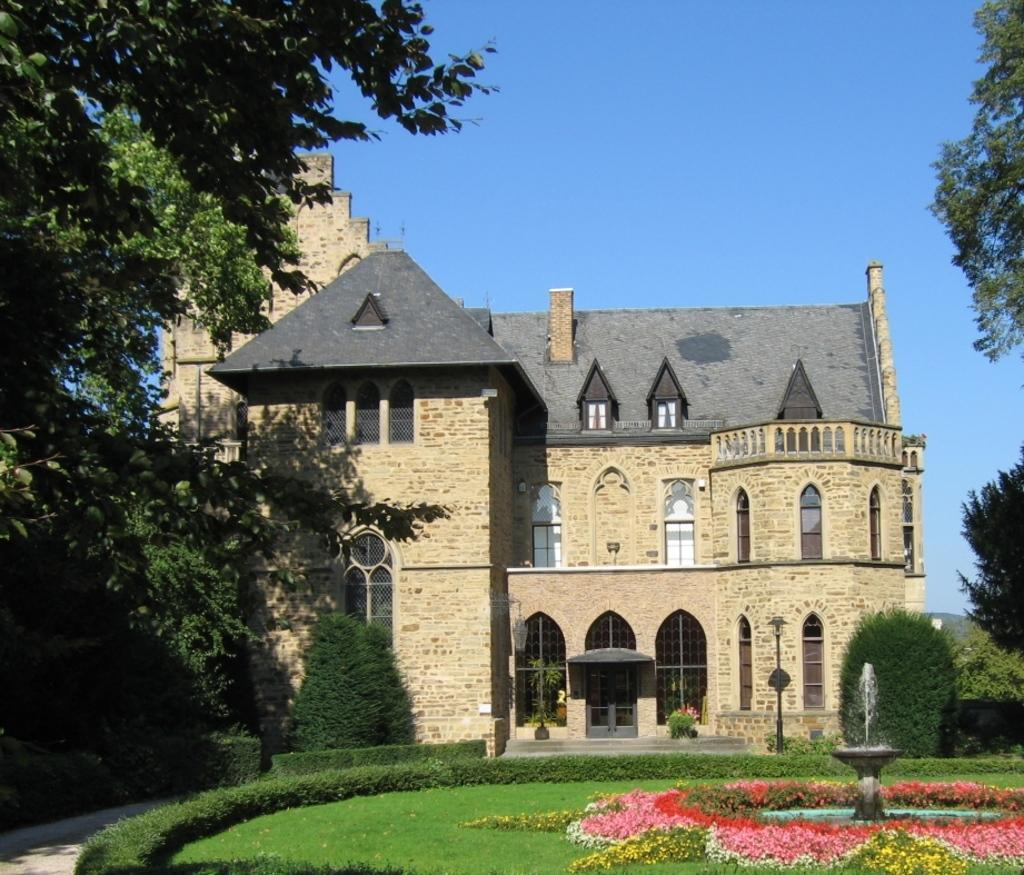What type of living organisms can be seen in the image? Plants and grass are visible in the image. What is located on the right side of the image? There is a small fountain on the right side of the image. What colors are present in the image? Pink, white, and yellow colors are present in the image. What type of meeting is taking place in the image? There is no meeting present in the image; it features plants, grass, and a small fountain. Who is the minister in the image? There is no minister present in the image. 